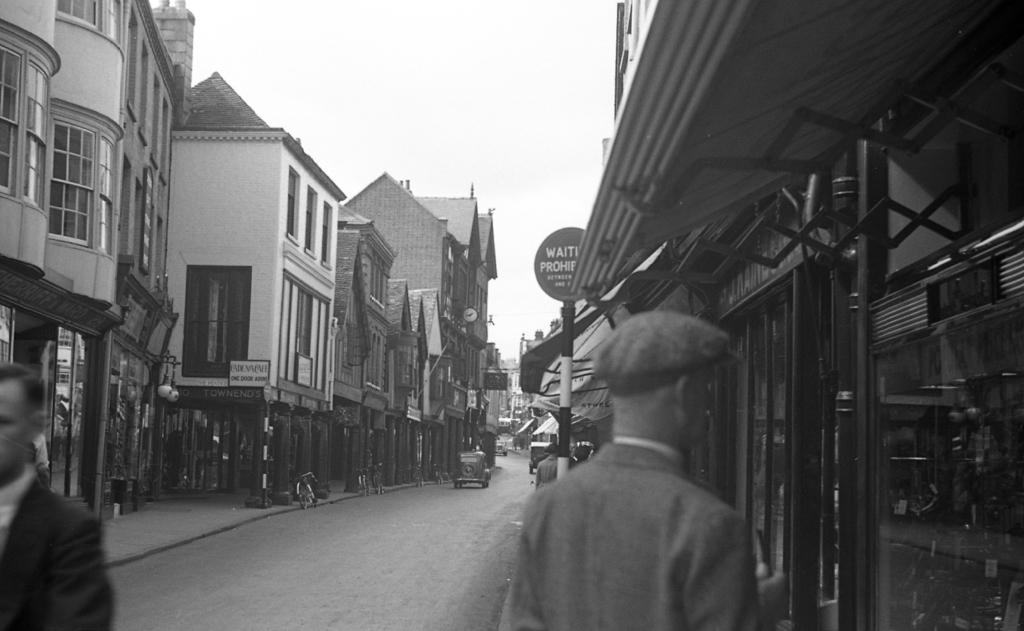What type of structures can be seen in the image? There are buildings in the image. What feature can be found on the buildings? There are windows in the image. What type of establishments are present in the image? There are stores in the image. What are the poles used for in the image? The poles are likely used for supporting signboards or other objects in the image. What can be seen on the poles? There are signboards in the image. What type of transportation is visible in the image? There are vehicles in the image. Who or what else can be seen in the image? There are people in the image. How is the image presented in terms of color? The image is in black and white. What type of beast can be seen roaming around in the image? There is no beast present in the image; it features buildings, windows, stores, poles, signboards, vehicles, and people. What kind of design can be seen on the ladybug in the image? There is no ladybug present in the image. 